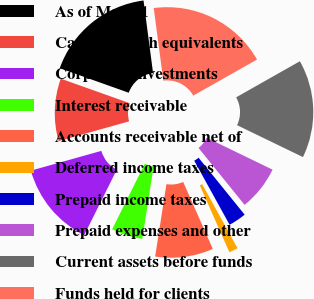Convert chart to OTSL. <chart><loc_0><loc_0><loc_500><loc_500><pie_chart><fcel>As of May 31<fcel>Cash and cash equivalents<fcel>Corporate investments<fcel>Interest receivable<fcel>Accounts receivable net of<fcel>Deferred income taxes<fcel>Prepaid income taxes<fcel>Prepaid expenses and other<fcel>Current assets before funds<fcel>Funds held for clients<nl><fcel>17.48%<fcel>9.79%<fcel>13.29%<fcel>4.9%<fcel>9.09%<fcel>1.4%<fcel>2.8%<fcel>6.99%<fcel>15.38%<fcel>18.88%<nl></chart> 